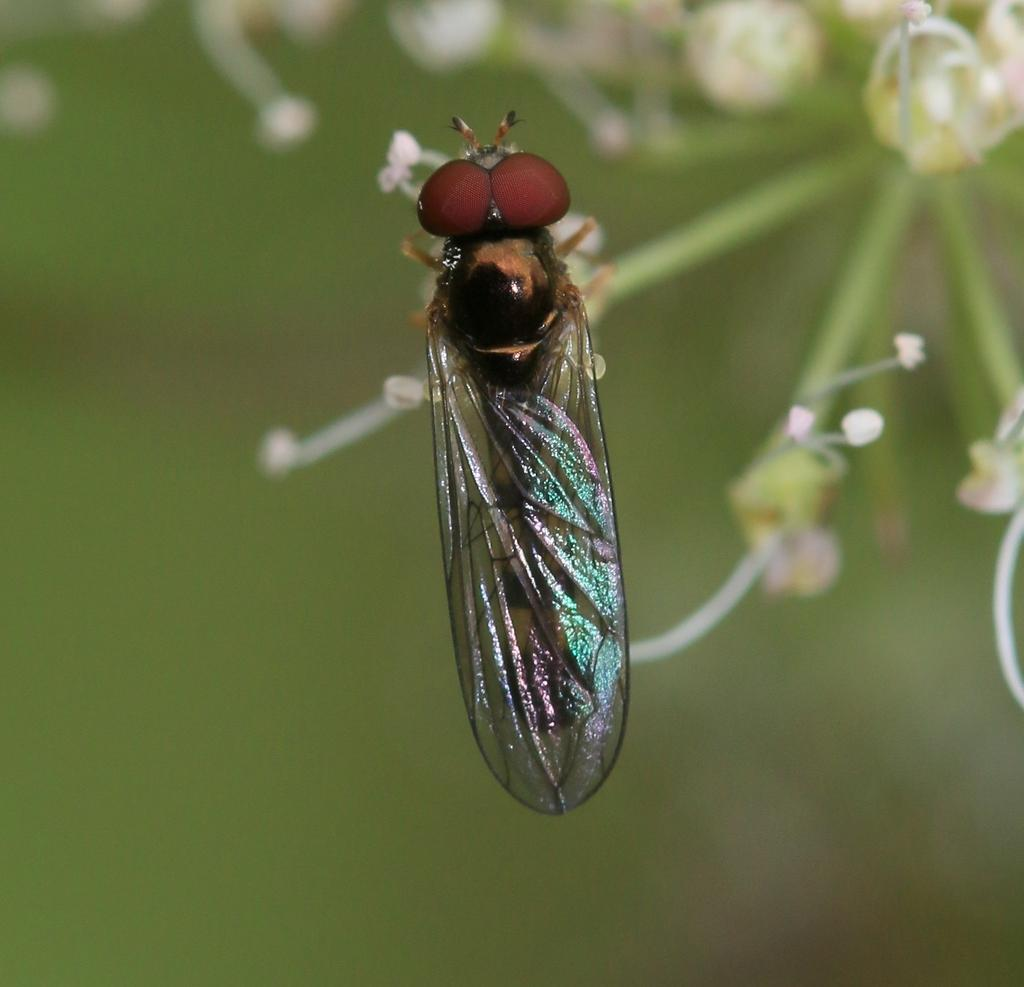What type of creature can be seen in the image? There is an insect in the image. What other objects or living organisms are present in the image? There are flowers in the image. Can you describe the background of the image? The background of the image is blurry. How many things are mentioned in the image's account? There is no mention of an account or things in the image; it simply features an insect and flowers with a blurry background. 